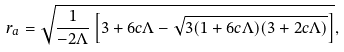<formula> <loc_0><loc_0><loc_500><loc_500>r _ { a } & = \sqrt { \frac { 1 } { - 2 \Lambda } \left [ 3 + 6 c \Lambda - \sqrt { 3 ( 1 + 6 c \Lambda ) ( 3 + 2 c \Lambda ) } \right ] } ,</formula> 